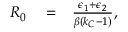<formula> <loc_0><loc_0><loc_500><loc_500>\begin{array} { r l r } { R _ { 0 } } & = } & { \frac { \epsilon _ { 1 } + \epsilon _ { 2 } } { \beta ( k _ { C } - 1 ) } , } \end{array}</formula> 